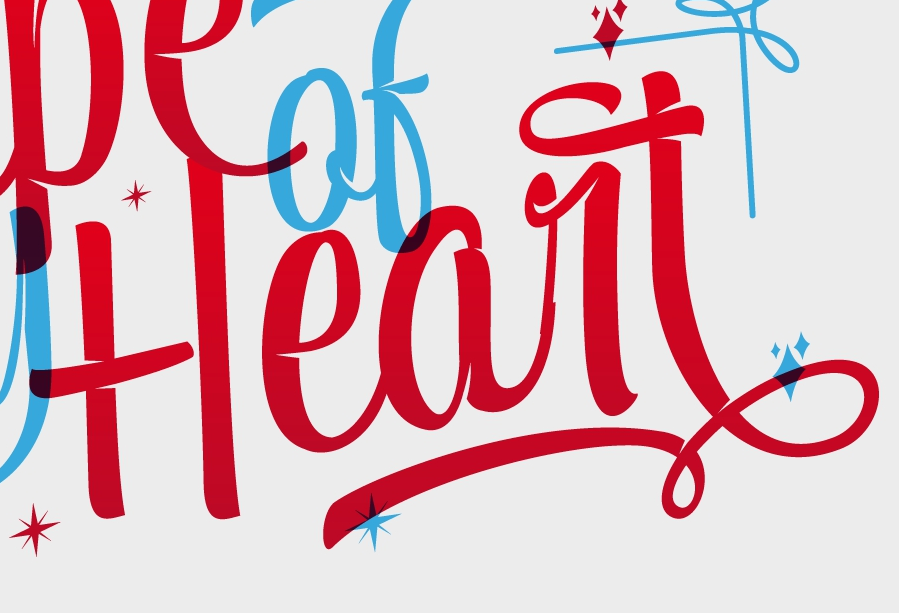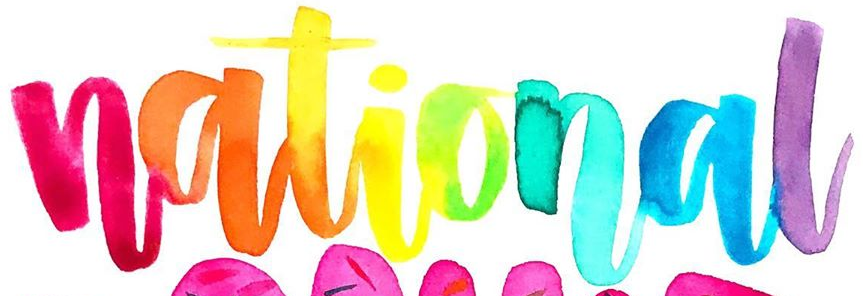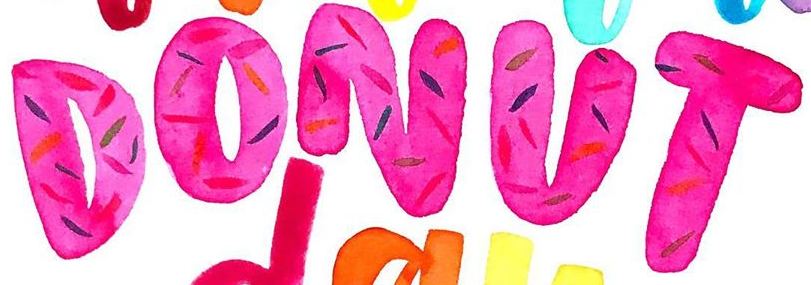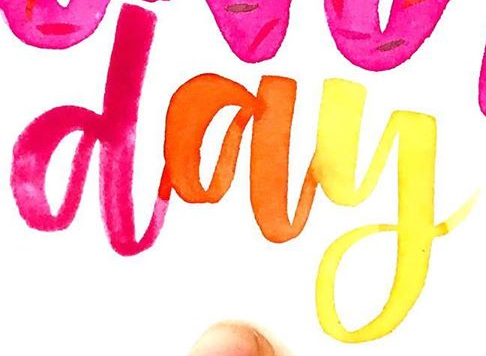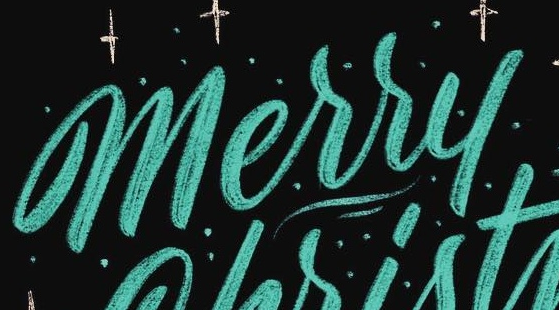Read the text content from these images in order, separated by a semicolon. Heart; national; DONUT; day; Merry 